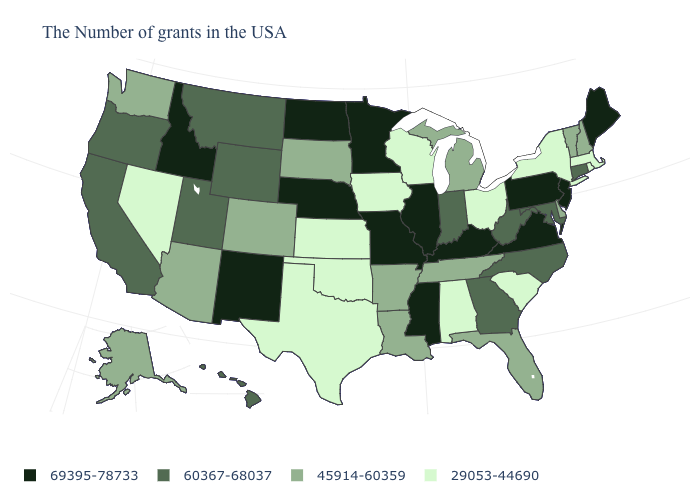What is the value of Iowa?
Answer briefly. 29053-44690. Is the legend a continuous bar?
Keep it brief. No. Among the states that border New York , does Vermont have the highest value?
Be succinct. No. What is the highest value in the West ?
Keep it brief. 69395-78733. What is the highest value in the USA?
Short answer required. 69395-78733. Which states hav the highest value in the Northeast?
Be succinct. Maine, New Jersey, Pennsylvania. Does Minnesota have a higher value than Oklahoma?
Short answer required. Yes. What is the highest value in the South ?
Concise answer only. 69395-78733. What is the highest value in the USA?
Quick response, please. 69395-78733. Does Iowa have the same value as South Carolina?
Give a very brief answer. Yes. Does Texas have the same value as North Dakota?
Quick response, please. No. Among the states that border Wisconsin , does Iowa have the lowest value?
Quick response, please. Yes. Does Hawaii have the highest value in the USA?
Answer briefly. No. Name the states that have a value in the range 69395-78733?
Quick response, please. Maine, New Jersey, Pennsylvania, Virginia, Kentucky, Illinois, Mississippi, Missouri, Minnesota, Nebraska, North Dakota, New Mexico, Idaho. Name the states that have a value in the range 45914-60359?
Short answer required. New Hampshire, Vermont, Delaware, Florida, Michigan, Tennessee, Louisiana, Arkansas, South Dakota, Colorado, Arizona, Washington, Alaska. 